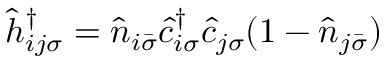Convert formula to latex. <formula><loc_0><loc_0><loc_500><loc_500>\hat { h } _ { i j \sigma } ^ { \dagger } = \hat { n } _ { i \bar { \sigma } } \hat { c } _ { i \sigma } ^ { \dagger } \hat { c } _ { j \sigma } ( 1 - \hat { n } _ { j \bar { \sigma } } )</formula> 